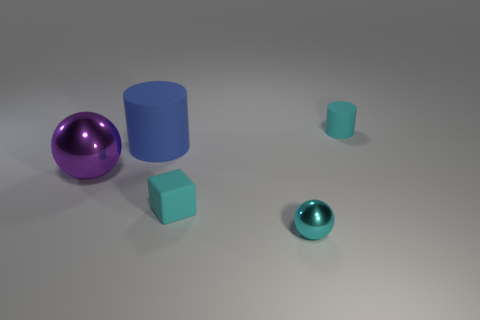Could you describe the spatial arrangement of the objects and what it might signify? The objects are arranged with ample space between them, on a flat surface. Starting from the left, there's a large purple sphere, a medium-sized blue cylinder standing upright, a small teal cylinder lying down, leading to the small cyan cube and then the tiny cyan sphere on the far right. This arrangement seems arbitrary but could suggest a gradient of sizes and an exploration of geometry, moving from curved to straight edges. 